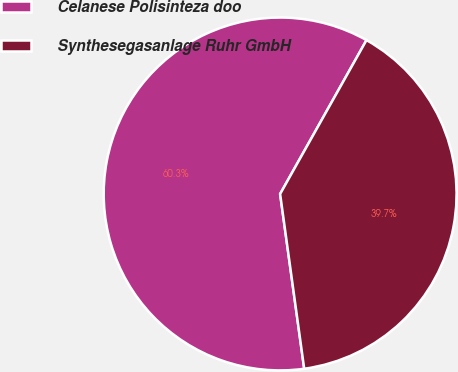Convert chart. <chart><loc_0><loc_0><loc_500><loc_500><pie_chart><fcel>Celanese Polisinteza doo<fcel>Synthesegasanlage Ruhr GmbH<nl><fcel>60.32%<fcel>39.68%<nl></chart> 